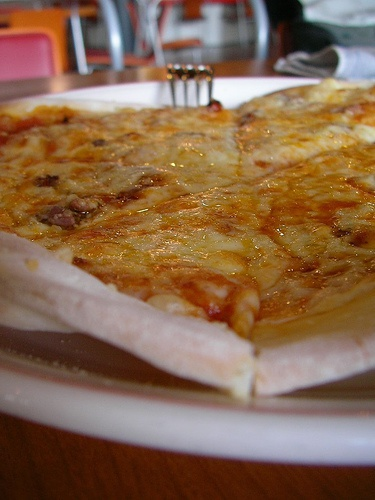Describe the objects in this image and their specific colors. I can see dining table in olive, gray, darkgray, and maroon tones, pizza in gray, olive, darkgray, and tan tones, chair in gray, brown, red, and salmon tones, and fork in gray, darkgray, and lightgray tones in this image. 